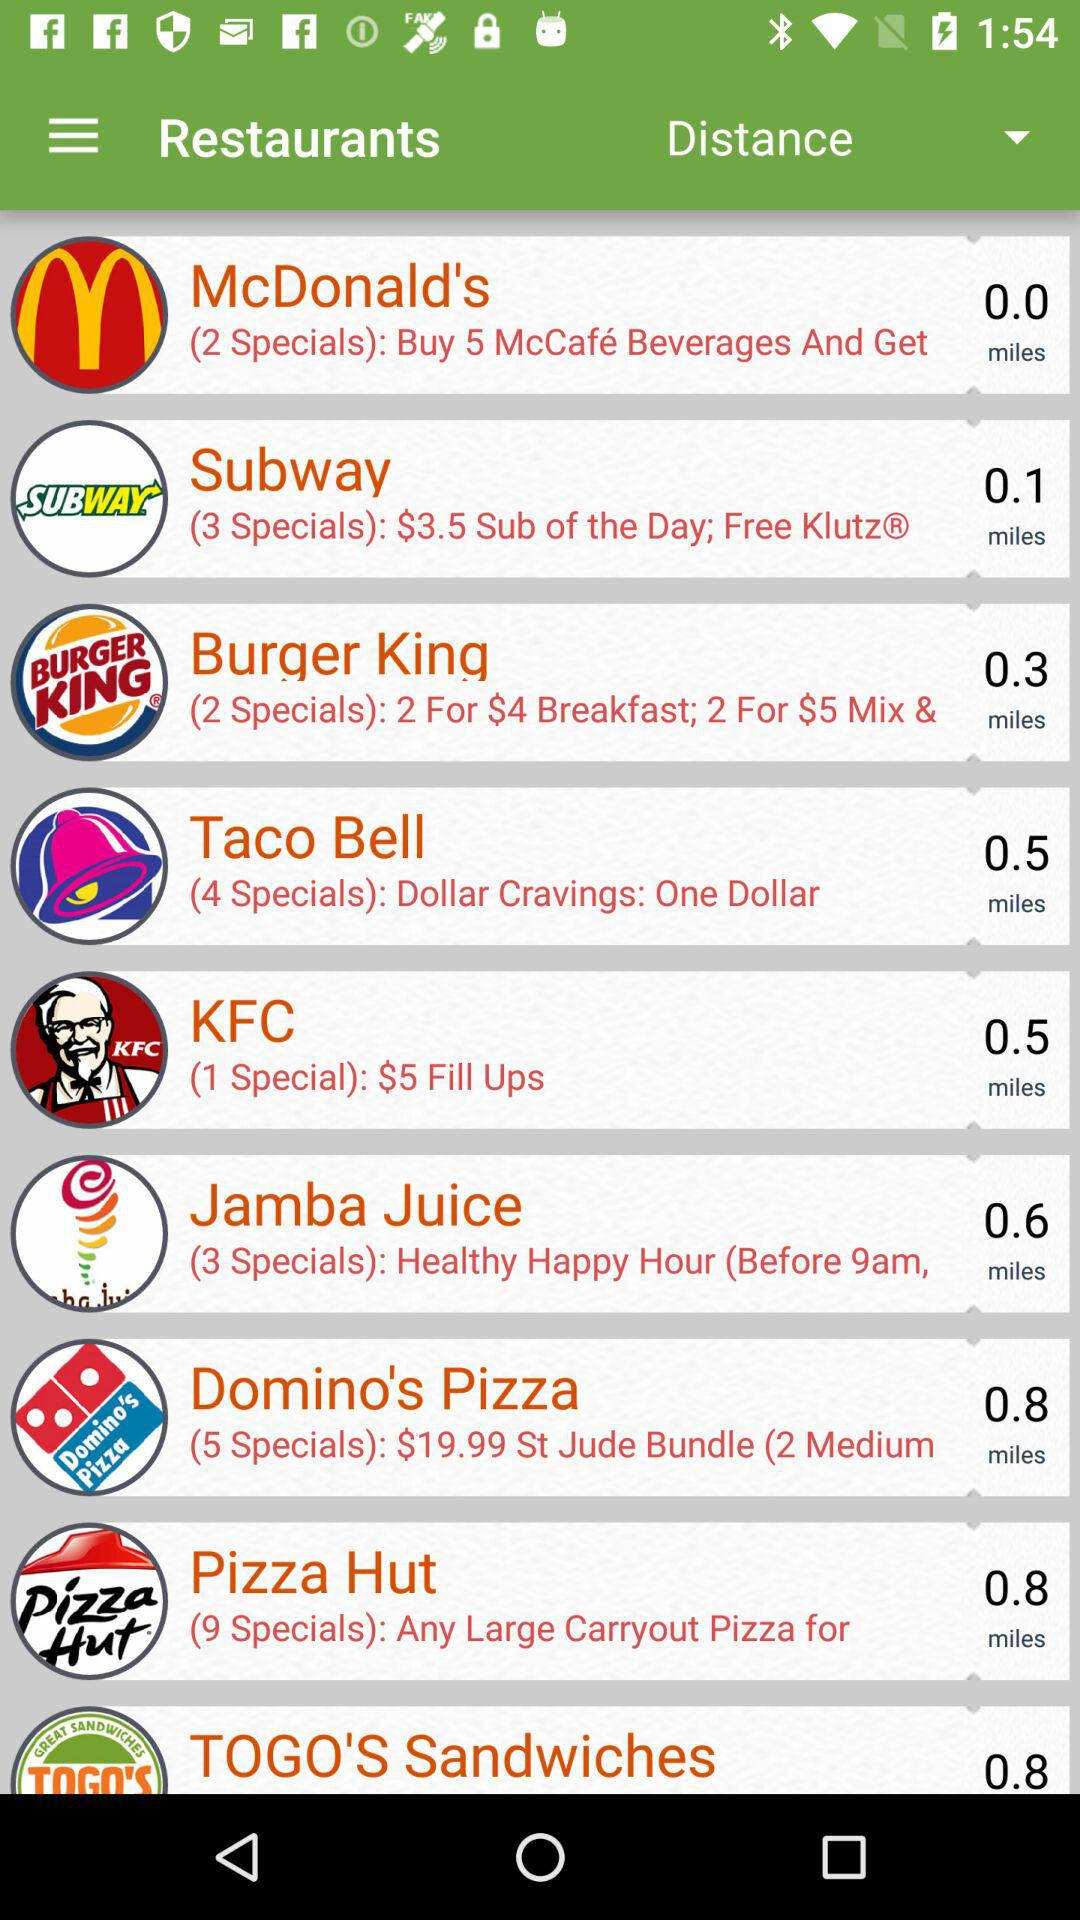How many restaurants have more than 2 specials?
Answer the question using a single word or phrase. 5 